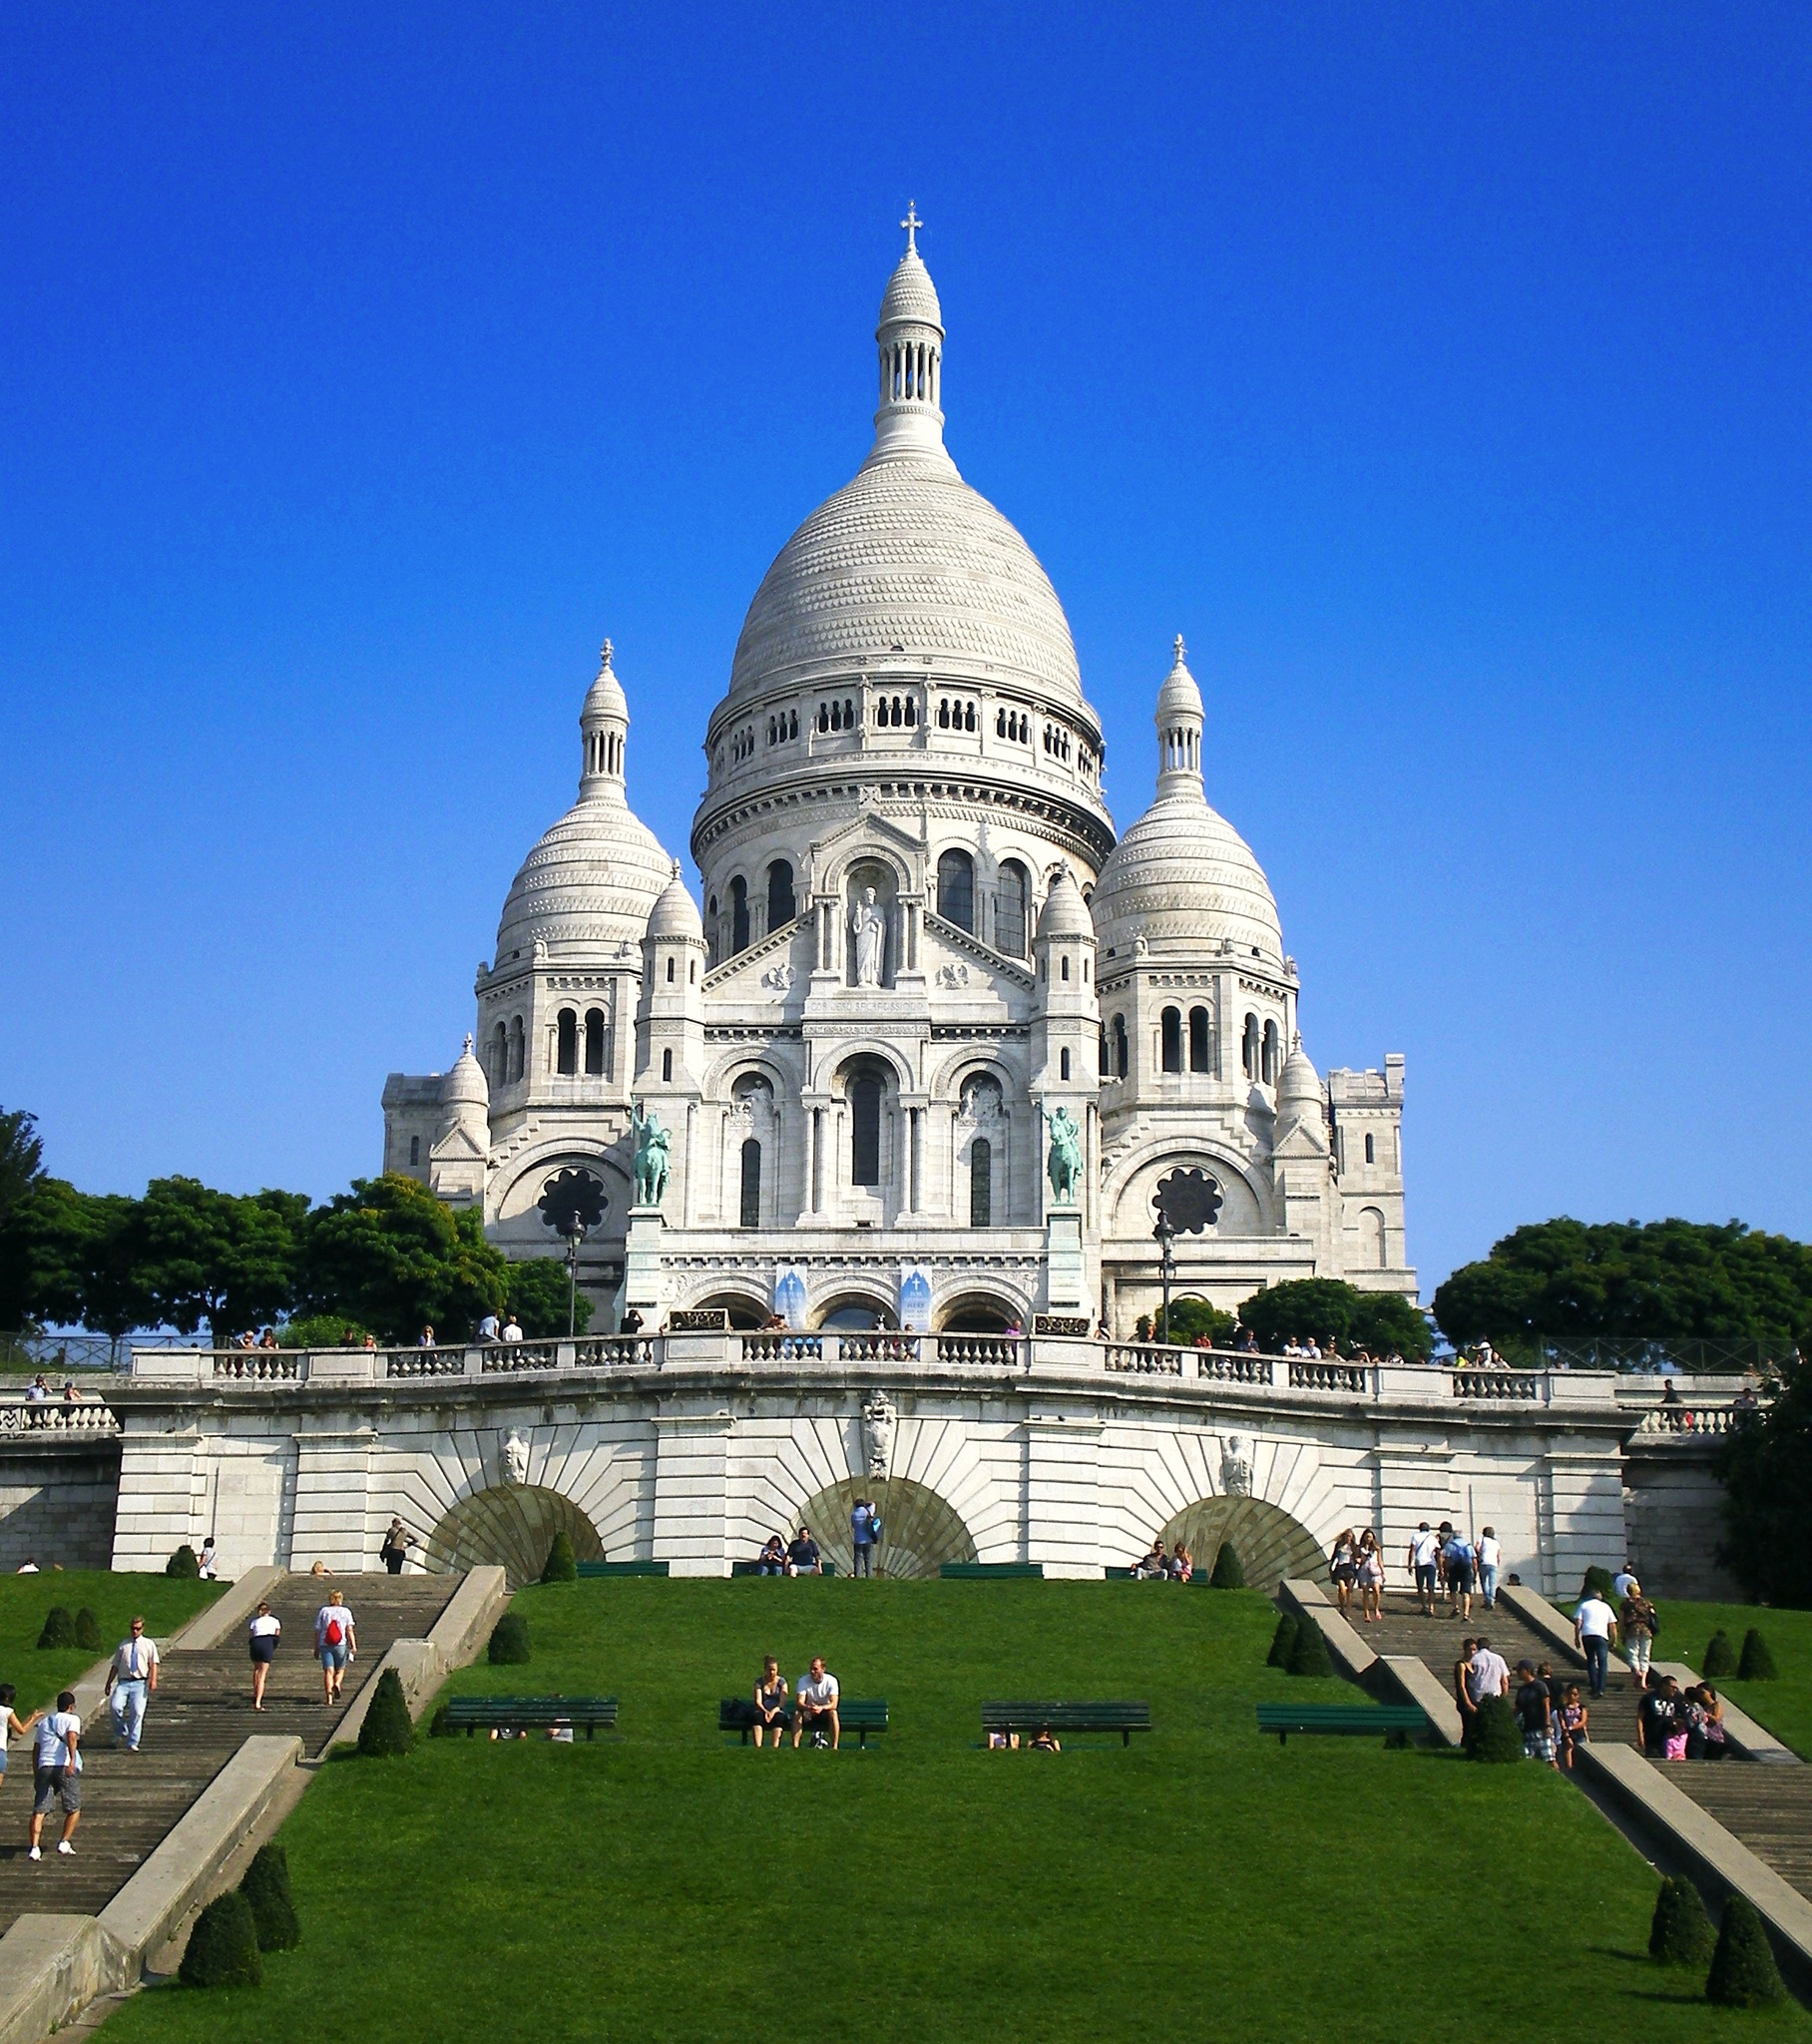Can you describe the main features of this image for me? The image showcases the stunning Sacré-Cœur Basilica, one of Paris's most visited monuments, known for its white travertine stone that exudes a glowing quality in sunlight. Located atop the Montmartre hill, the highest point in the city, this basilica is not only a religious site but also a cultural icon, drawing visitors who appreciate its Byzantine and Romanesque architectural styles. Prominent features visible in this image include its grand domes and the ornate bell tower. The viewers can also see the expansive front lawn, where visitors and locals alike relax and soak in the panoramic views of Paris that the hilltop location offers. This perspective, likely taken from a typical tourist's vantage point, perfectly encapsulates the beauty and the inviting atmosphere of the Sacré-Cœur and its surroundings. 